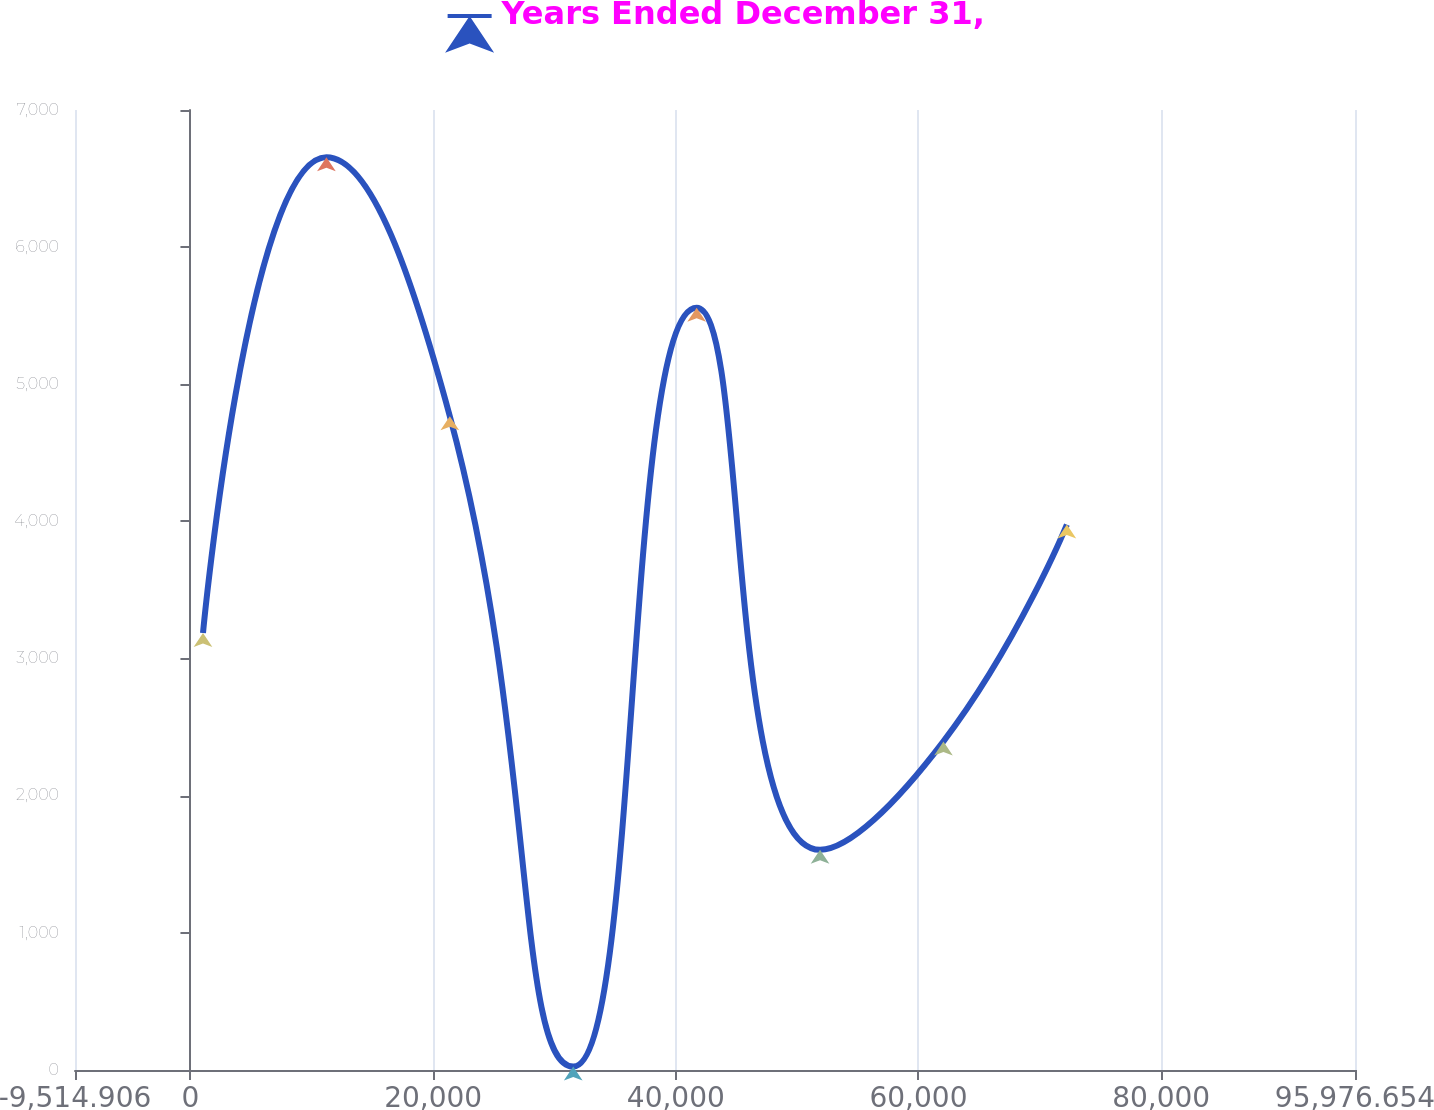Convert chart to OTSL. <chart><loc_0><loc_0><loc_500><loc_500><line_chart><ecel><fcel>Years Ended December 31,<nl><fcel>1034.25<fcel>3186.61<nl><fcel>11205.2<fcel>6655.27<nl><fcel>21376.1<fcel>4767.57<nl><fcel>31547<fcel>24.71<nl><fcel>41718<fcel>5558.05<nl><fcel>51888.9<fcel>1605.66<nl><fcel>62059.8<fcel>2396.14<nl><fcel>72230.8<fcel>3977.09<nl><fcel>96354.9<fcel>815.19<nl><fcel>106526<fcel>7929.46<nl></chart> 